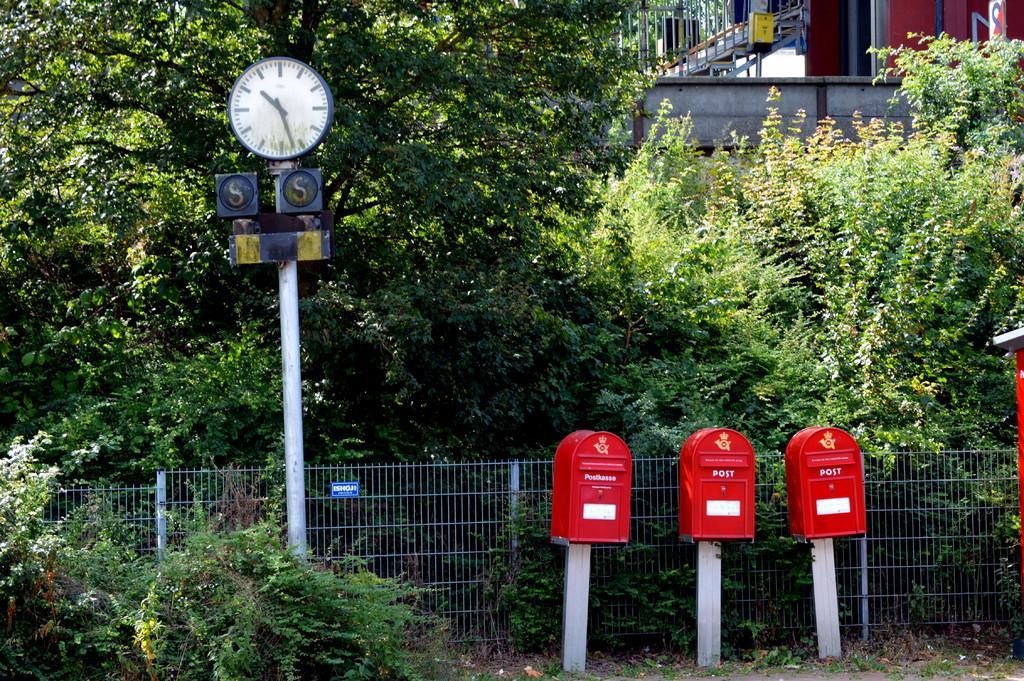How would you summarize this image in a sentence or two? This is a picture of a place where we have three post boxes and behind there is a fencing, trees, plants and a house to which there is a staircase and a fencing to it. 